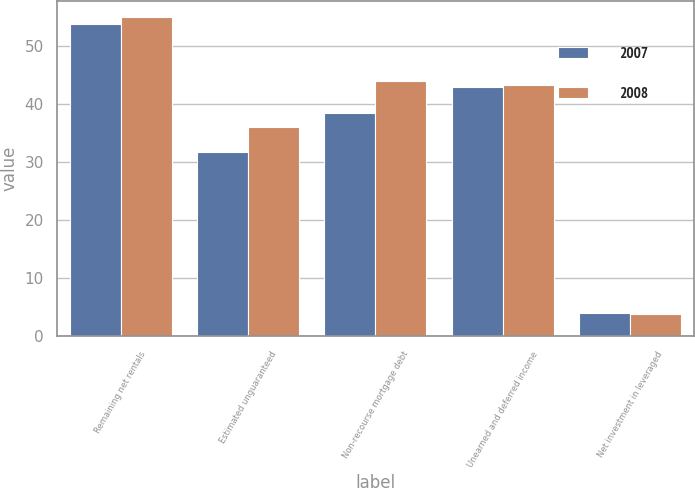Convert chart to OTSL. <chart><loc_0><loc_0><loc_500><loc_500><stacked_bar_chart><ecel><fcel>Remaining net rentals<fcel>Estimated unguaranteed<fcel>Non-recourse mortgage debt<fcel>Unearned and deferred income<fcel>Net investment in leveraged<nl><fcel>2007<fcel>53.8<fcel>31.7<fcel>38.5<fcel>43<fcel>4<nl><fcel>2008<fcel>55<fcel>36<fcel>43.9<fcel>43.3<fcel>3.8<nl></chart> 